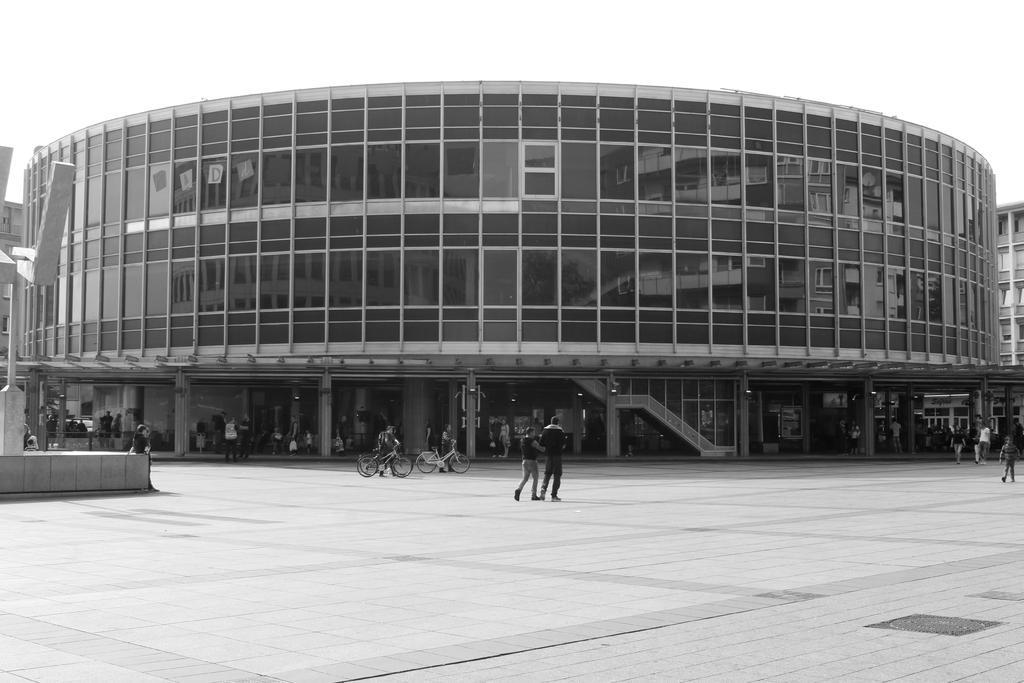Can you describe this image briefly? This image is taken outdoors. This image is a black and white image. At the bottom of the image there is a floor. In the middle of the image a few are walking on the road and two men are holding bicycles in their hands. There is a building with walls, windows, pillars, doors and roofs. A few people are standing on the sidewalk. On the left side of the image there is an architecture. 